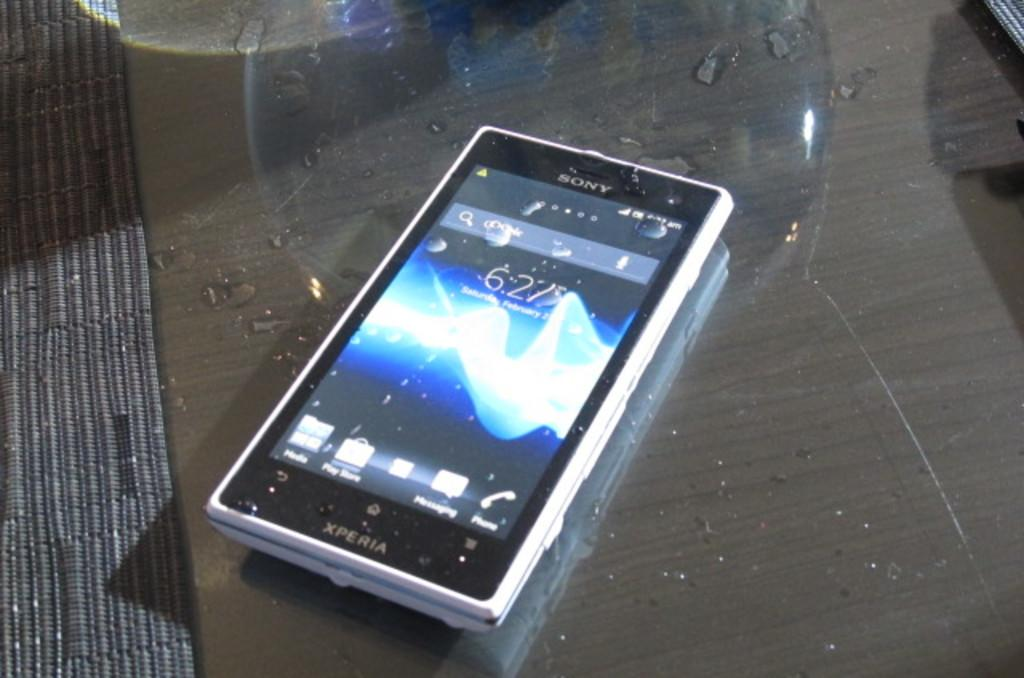<image>
Relay a brief, clear account of the picture shown. Old cell phone that is made by Xperia on a table 